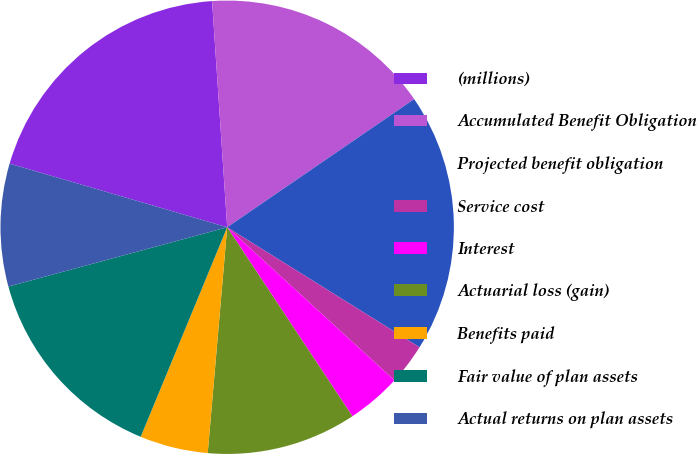<chart> <loc_0><loc_0><loc_500><loc_500><pie_chart><fcel>(millions)<fcel>Accumulated Benefit Obligation<fcel>Projected benefit obligation<fcel>Service cost<fcel>Interest<fcel>Actuarial loss (gain)<fcel>Benefits paid<fcel>Fair value of plan assets<fcel>Actual returns on plan assets<nl><fcel>19.41%<fcel>16.5%<fcel>18.44%<fcel>2.92%<fcel>3.89%<fcel>10.68%<fcel>4.86%<fcel>14.56%<fcel>8.74%<nl></chart> 